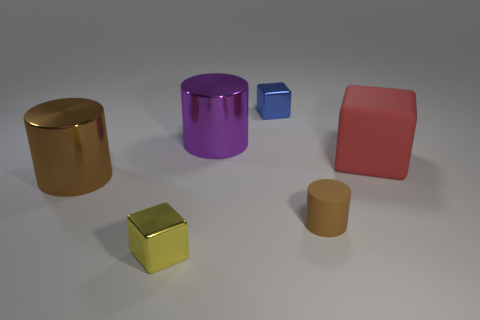Subtract 1 blocks. How many blocks are left? 2 Add 1 big purple cylinders. How many objects exist? 7 Subtract all yellow metallic cubes. Subtract all tiny brown objects. How many objects are left? 4 Add 2 tiny matte cylinders. How many tiny matte cylinders are left? 3 Add 3 green blocks. How many green blocks exist? 3 Subtract 0 gray spheres. How many objects are left? 6 